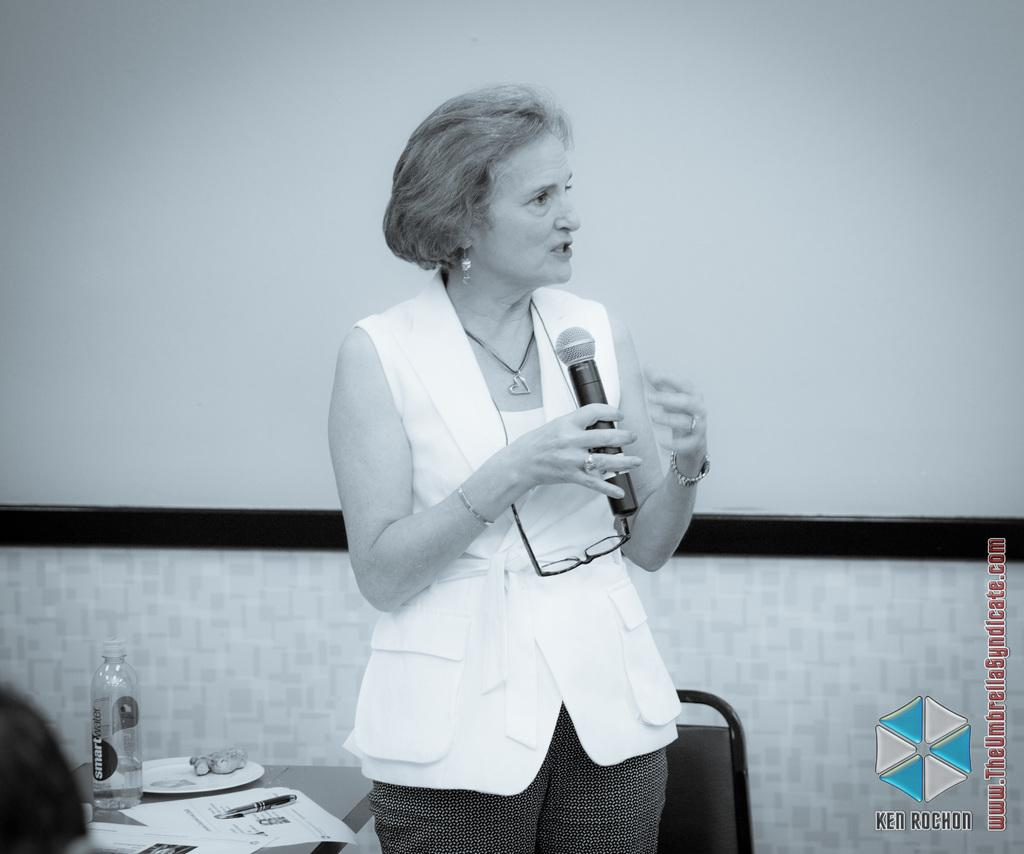Who is the main subject in the image? There is a woman in the image. What is the woman doing in the image? The woman is standing and holding a mic. What objects are near the woman in the image? There is a table next to the woman and a chair in the background of the image. What can be seen in the background of the image? There is a wall in the background of the image. What type of pest can be seen in the image? There are no pests visible in the image. 